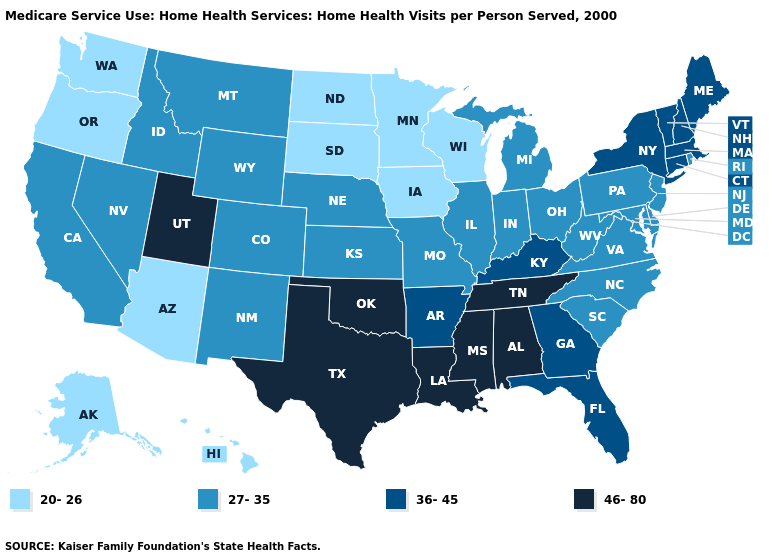Does Illinois have the same value as Tennessee?
Give a very brief answer. No. Among the states that border Indiana , does Kentucky have the lowest value?
Concise answer only. No. What is the highest value in the USA?
Give a very brief answer. 46-80. Name the states that have a value in the range 46-80?
Give a very brief answer. Alabama, Louisiana, Mississippi, Oklahoma, Tennessee, Texas, Utah. Name the states that have a value in the range 46-80?
Quick response, please. Alabama, Louisiana, Mississippi, Oklahoma, Tennessee, Texas, Utah. Name the states that have a value in the range 36-45?
Keep it brief. Arkansas, Connecticut, Florida, Georgia, Kentucky, Maine, Massachusetts, New Hampshire, New York, Vermont. Does South Carolina have a lower value than Massachusetts?
Give a very brief answer. Yes. Does West Virginia have the highest value in the USA?
Write a very short answer. No. Does Iowa have the lowest value in the USA?
Quick response, please. Yes. Which states hav the highest value in the MidWest?
Quick response, please. Illinois, Indiana, Kansas, Michigan, Missouri, Nebraska, Ohio. Name the states that have a value in the range 27-35?
Keep it brief. California, Colorado, Delaware, Idaho, Illinois, Indiana, Kansas, Maryland, Michigan, Missouri, Montana, Nebraska, Nevada, New Jersey, New Mexico, North Carolina, Ohio, Pennsylvania, Rhode Island, South Carolina, Virginia, West Virginia, Wyoming. Name the states that have a value in the range 20-26?
Concise answer only. Alaska, Arizona, Hawaii, Iowa, Minnesota, North Dakota, Oregon, South Dakota, Washington, Wisconsin. Does Washington have the lowest value in the USA?
Answer briefly. Yes. How many symbols are there in the legend?
Concise answer only. 4. What is the value of Wyoming?
Quick response, please. 27-35. 